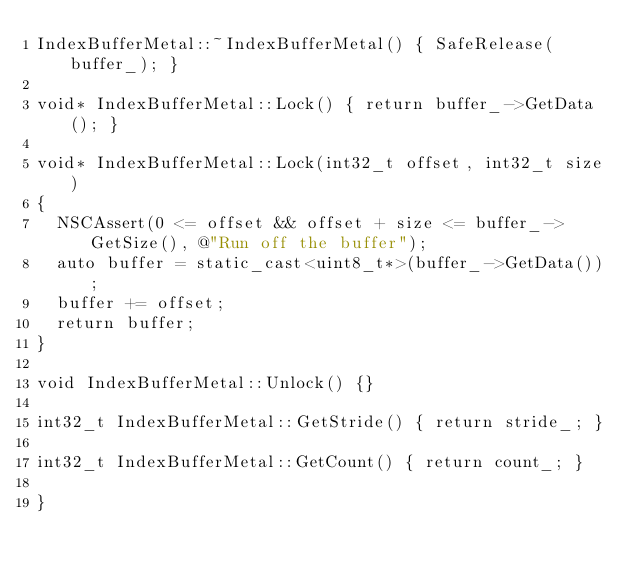<code> <loc_0><loc_0><loc_500><loc_500><_ObjectiveC_>IndexBufferMetal::~IndexBufferMetal() { SafeRelease(buffer_); }

void* IndexBufferMetal::Lock() { return buffer_->GetData(); }

void* IndexBufferMetal::Lock(int32_t offset, int32_t size)
{
	NSCAssert(0 <= offset && offset + size <= buffer_->GetSize(), @"Run off the buffer");
	auto buffer = static_cast<uint8_t*>(buffer_->GetData());
	buffer += offset;
	return buffer;
}

void IndexBufferMetal::Unlock() {}

int32_t IndexBufferMetal::GetStride() { return stride_; }

int32_t IndexBufferMetal::GetCount() { return count_; }

}
</code> 